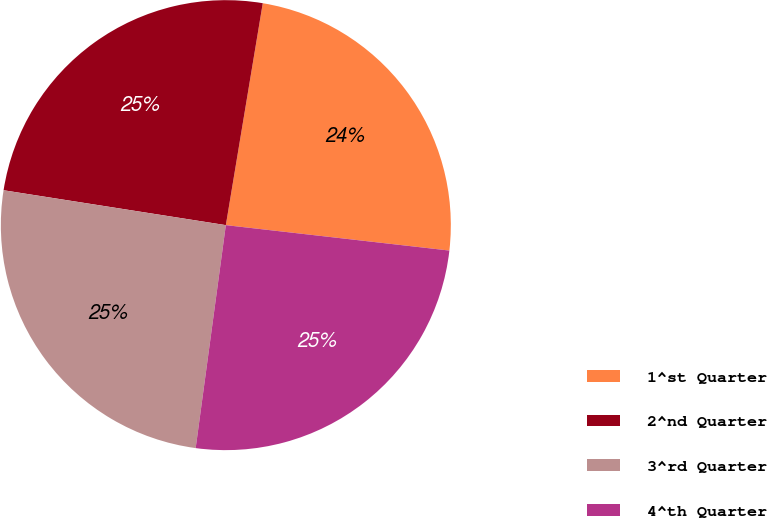<chart> <loc_0><loc_0><loc_500><loc_500><pie_chart><fcel>1^st Quarter<fcel>2^nd Quarter<fcel>3^rd Quarter<fcel>4^th Quarter<nl><fcel>24.18%<fcel>25.15%<fcel>25.34%<fcel>25.34%<nl></chart> 